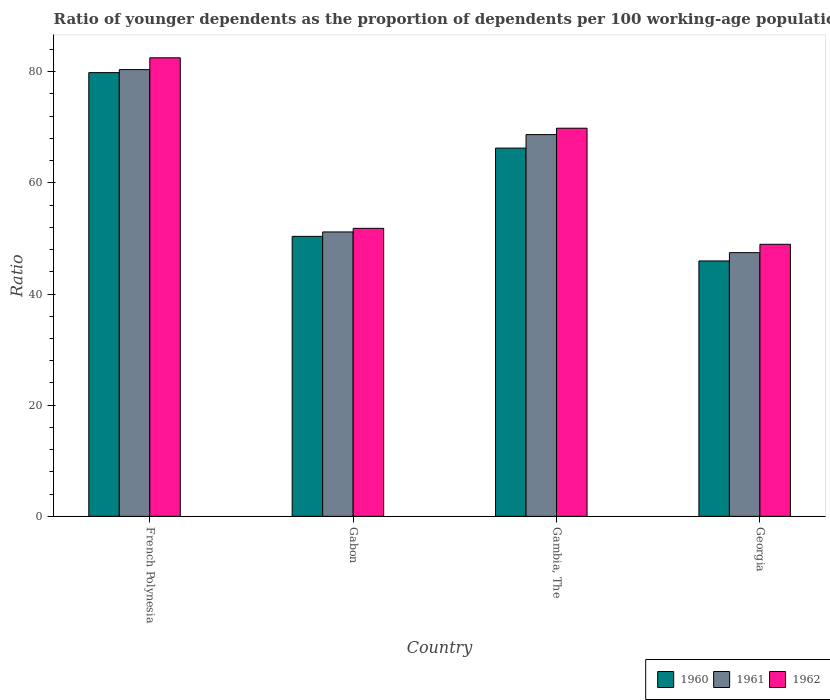Are the number of bars on each tick of the X-axis equal?
Give a very brief answer. Yes. How many bars are there on the 2nd tick from the left?
Provide a short and direct response. 3. What is the label of the 3rd group of bars from the left?
Your response must be concise. Gambia, The. In how many cases, is the number of bars for a given country not equal to the number of legend labels?
Provide a succinct answer. 0. What is the age dependency ratio(young) in 1961 in French Polynesia?
Your answer should be compact. 80.38. Across all countries, what is the maximum age dependency ratio(young) in 1960?
Provide a succinct answer. 79.84. Across all countries, what is the minimum age dependency ratio(young) in 1960?
Provide a succinct answer. 45.95. In which country was the age dependency ratio(young) in 1960 maximum?
Your response must be concise. French Polynesia. In which country was the age dependency ratio(young) in 1961 minimum?
Offer a terse response. Georgia. What is the total age dependency ratio(young) in 1961 in the graph?
Offer a terse response. 247.68. What is the difference between the age dependency ratio(young) in 1960 in Gambia, The and that in Georgia?
Ensure brevity in your answer.  20.31. What is the difference between the age dependency ratio(young) in 1961 in French Polynesia and the age dependency ratio(young) in 1962 in Gambia, The?
Ensure brevity in your answer.  10.54. What is the average age dependency ratio(young) in 1961 per country?
Keep it short and to the point. 61.92. What is the difference between the age dependency ratio(young) of/in 1960 and age dependency ratio(young) of/in 1962 in Georgia?
Provide a succinct answer. -3. What is the ratio of the age dependency ratio(young) in 1961 in French Polynesia to that in Gambia, The?
Your answer should be compact. 1.17. What is the difference between the highest and the second highest age dependency ratio(young) in 1962?
Your answer should be compact. 30.68. What is the difference between the highest and the lowest age dependency ratio(young) in 1960?
Make the answer very short. 33.89. Is the sum of the age dependency ratio(young) in 1960 in French Polynesia and Georgia greater than the maximum age dependency ratio(young) in 1962 across all countries?
Make the answer very short. Yes. What is the difference between two consecutive major ticks on the Y-axis?
Keep it short and to the point. 20. Does the graph contain any zero values?
Keep it short and to the point. No. Does the graph contain grids?
Offer a very short reply. No. How many legend labels are there?
Keep it short and to the point. 3. What is the title of the graph?
Your answer should be compact. Ratio of younger dependents as the proportion of dependents per 100 working-age population. What is the label or title of the X-axis?
Your response must be concise. Country. What is the label or title of the Y-axis?
Provide a short and direct response. Ratio. What is the Ratio in 1960 in French Polynesia?
Make the answer very short. 79.84. What is the Ratio of 1961 in French Polynesia?
Keep it short and to the point. 80.38. What is the Ratio of 1962 in French Polynesia?
Your response must be concise. 82.5. What is the Ratio of 1960 in Gabon?
Offer a terse response. 50.38. What is the Ratio in 1961 in Gabon?
Keep it short and to the point. 51.17. What is the Ratio of 1962 in Gabon?
Provide a succinct answer. 51.82. What is the Ratio in 1960 in Gambia, The?
Offer a terse response. 66.26. What is the Ratio in 1961 in Gambia, The?
Your answer should be compact. 68.69. What is the Ratio of 1962 in Gambia, The?
Your answer should be very brief. 69.84. What is the Ratio of 1960 in Georgia?
Provide a succinct answer. 45.95. What is the Ratio in 1961 in Georgia?
Keep it short and to the point. 47.45. What is the Ratio of 1962 in Georgia?
Keep it short and to the point. 48.95. Across all countries, what is the maximum Ratio of 1960?
Your answer should be compact. 79.84. Across all countries, what is the maximum Ratio in 1961?
Offer a terse response. 80.38. Across all countries, what is the maximum Ratio of 1962?
Offer a terse response. 82.5. Across all countries, what is the minimum Ratio in 1960?
Ensure brevity in your answer.  45.95. Across all countries, what is the minimum Ratio in 1961?
Keep it short and to the point. 47.45. Across all countries, what is the minimum Ratio in 1962?
Your answer should be compact. 48.95. What is the total Ratio of 1960 in the graph?
Your response must be concise. 242.42. What is the total Ratio of 1961 in the graph?
Provide a succinct answer. 247.68. What is the total Ratio of 1962 in the graph?
Ensure brevity in your answer.  253.11. What is the difference between the Ratio in 1960 in French Polynesia and that in Gabon?
Provide a short and direct response. 29.46. What is the difference between the Ratio of 1961 in French Polynesia and that in Gabon?
Offer a terse response. 29.21. What is the difference between the Ratio of 1962 in French Polynesia and that in Gabon?
Ensure brevity in your answer.  30.68. What is the difference between the Ratio of 1960 in French Polynesia and that in Gambia, The?
Your answer should be very brief. 13.58. What is the difference between the Ratio in 1961 in French Polynesia and that in Gambia, The?
Your answer should be compact. 11.69. What is the difference between the Ratio of 1962 in French Polynesia and that in Gambia, The?
Keep it short and to the point. 12.67. What is the difference between the Ratio of 1960 in French Polynesia and that in Georgia?
Give a very brief answer. 33.89. What is the difference between the Ratio of 1961 in French Polynesia and that in Georgia?
Offer a very short reply. 32.93. What is the difference between the Ratio in 1962 in French Polynesia and that in Georgia?
Your response must be concise. 33.56. What is the difference between the Ratio of 1960 in Gabon and that in Gambia, The?
Give a very brief answer. -15.88. What is the difference between the Ratio in 1961 in Gabon and that in Gambia, The?
Your answer should be very brief. -17.51. What is the difference between the Ratio of 1962 in Gabon and that in Gambia, The?
Your response must be concise. -18.02. What is the difference between the Ratio of 1960 in Gabon and that in Georgia?
Your answer should be very brief. 4.42. What is the difference between the Ratio of 1961 in Gabon and that in Georgia?
Your answer should be very brief. 3.73. What is the difference between the Ratio in 1962 in Gabon and that in Georgia?
Your response must be concise. 2.87. What is the difference between the Ratio in 1960 in Gambia, The and that in Georgia?
Make the answer very short. 20.31. What is the difference between the Ratio of 1961 in Gambia, The and that in Georgia?
Offer a terse response. 21.24. What is the difference between the Ratio in 1962 in Gambia, The and that in Georgia?
Provide a short and direct response. 20.89. What is the difference between the Ratio of 1960 in French Polynesia and the Ratio of 1961 in Gabon?
Provide a short and direct response. 28.67. What is the difference between the Ratio of 1960 in French Polynesia and the Ratio of 1962 in Gabon?
Ensure brevity in your answer.  28.02. What is the difference between the Ratio of 1961 in French Polynesia and the Ratio of 1962 in Gabon?
Your answer should be very brief. 28.56. What is the difference between the Ratio of 1960 in French Polynesia and the Ratio of 1961 in Gambia, The?
Your response must be concise. 11.15. What is the difference between the Ratio in 1960 in French Polynesia and the Ratio in 1962 in Gambia, The?
Provide a short and direct response. 10. What is the difference between the Ratio of 1961 in French Polynesia and the Ratio of 1962 in Gambia, The?
Provide a short and direct response. 10.54. What is the difference between the Ratio in 1960 in French Polynesia and the Ratio in 1961 in Georgia?
Provide a short and direct response. 32.39. What is the difference between the Ratio of 1960 in French Polynesia and the Ratio of 1962 in Georgia?
Your answer should be compact. 30.89. What is the difference between the Ratio of 1961 in French Polynesia and the Ratio of 1962 in Georgia?
Provide a short and direct response. 31.43. What is the difference between the Ratio in 1960 in Gabon and the Ratio in 1961 in Gambia, The?
Your answer should be compact. -18.31. What is the difference between the Ratio in 1960 in Gabon and the Ratio in 1962 in Gambia, The?
Give a very brief answer. -19.46. What is the difference between the Ratio of 1961 in Gabon and the Ratio of 1962 in Gambia, The?
Your answer should be compact. -18.66. What is the difference between the Ratio of 1960 in Gabon and the Ratio of 1961 in Georgia?
Your response must be concise. 2.93. What is the difference between the Ratio of 1960 in Gabon and the Ratio of 1962 in Georgia?
Give a very brief answer. 1.43. What is the difference between the Ratio in 1961 in Gabon and the Ratio in 1962 in Georgia?
Give a very brief answer. 2.22. What is the difference between the Ratio of 1960 in Gambia, The and the Ratio of 1961 in Georgia?
Ensure brevity in your answer.  18.81. What is the difference between the Ratio in 1960 in Gambia, The and the Ratio in 1962 in Georgia?
Make the answer very short. 17.31. What is the difference between the Ratio in 1961 in Gambia, The and the Ratio in 1962 in Georgia?
Provide a short and direct response. 19.74. What is the average Ratio in 1960 per country?
Give a very brief answer. 60.61. What is the average Ratio in 1961 per country?
Offer a very short reply. 61.92. What is the average Ratio in 1962 per country?
Give a very brief answer. 63.28. What is the difference between the Ratio of 1960 and Ratio of 1961 in French Polynesia?
Offer a very short reply. -0.54. What is the difference between the Ratio of 1960 and Ratio of 1962 in French Polynesia?
Make the answer very short. -2.67. What is the difference between the Ratio of 1961 and Ratio of 1962 in French Polynesia?
Provide a succinct answer. -2.13. What is the difference between the Ratio in 1960 and Ratio in 1961 in Gabon?
Provide a short and direct response. -0.8. What is the difference between the Ratio of 1960 and Ratio of 1962 in Gabon?
Give a very brief answer. -1.45. What is the difference between the Ratio of 1961 and Ratio of 1962 in Gabon?
Ensure brevity in your answer.  -0.65. What is the difference between the Ratio of 1960 and Ratio of 1961 in Gambia, The?
Give a very brief answer. -2.43. What is the difference between the Ratio in 1960 and Ratio in 1962 in Gambia, The?
Offer a terse response. -3.58. What is the difference between the Ratio of 1961 and Ratio of 1962 in Gambia, The?
Ensure brevity in your answer.  -1.15. What is the difference between the Ratio in 1960 and Ratio in 1961 in Georgia?
Provide a short and direct response. -1.49. What is the difference between the Ratio of 1960 and Ratio of 1962 in Georgia?
Offer a terse response. -3. What is the difference between the Ratio in 1961 and Ratio in 1962 in Georgia?
Provide a short and direct response. -1.5. What is the ratio of the Ratio of 1960 in French Polynesia to that in Gabon?
Make the answer very short. 1.58. What is the ratio of the Ratio in 1961 in French Polynesia to that in Gabon?
Give a very brief answer. 1.57. What is the ratio of the Ratio in 1962 in French Polynesia to that in Gabon?
Offer a very short reply. 1.59. What is the ratio of the Ratio of 1960 in French Polynesia to that in Gambia, The?
Provide a succinct answer. 1.21. What is the ratio of the Ratio in 1961 in French Polynesia to that in Gambia, The?
Offer a very short reply. 1.17. What is the ratio of the Ratio of 1962 in French Polynesia to that in Gambia, The?
Provide a short and direct response. 1.18. What is the ratio of the Ratio in 1960 in French Polynesia to that in Georgia?
Provide a succinct answer. 1.74. What is the ratio of the Ratio in 1961 in French Polynesia to that in Georgia?
Ensure brevity in your answer.  1.69. What is the ratio of the Ratio in 1962 in French Polynesia to that in Georgia?
Offer a terse response. 1.69. What is the ratio of the Ratio of 1960 in Gabon to that in Gambia, The?
Make the answer very short. 0.76. What is the ratio of the Ratio of 1961 in Gabon to that in Gambia, The?
Give a very brief answer. 0.74. What is the ratio of the Ratio in 1962 in Gabon to that in Gambia, The?
Your response must be concise. 0.74. What is the ratio of the Ratio of 1960 in Gabon to that in Georgia?
Offer a terse response. 1.1. What is the ratio of the Ratio in 1961 in Gabon to that in Georgia?
Provide a short and direct response. 1.08. What is the ratio of the Ratio in 1962 in Gabon to that in Georgia?
Your response must be concise. 1.06. What is the ratio of the Ratio of 1960 in Gambia, The to that in Georgia?
Offer a very short reply. 1.44. What is the ratio of the Ratio of 1961 in Gambia, The to that in Georgia?
Keep it short and to the point. 1.45. What is the ratio of the Ratio of 1962 in Gambia, The to that in Georgia?
Your answer should be very brief. 1.43. What is the difference between the highest and the second highest Ratio of 1960?
Your answer should be very brief. 13.58. What is the difference between the highest and the second highest Ratio of 1961?
Offer a terse response. 11.69. What is the difference between the highest and the second highest Ratio in 1962?
Your answer should be compact. 12.67. What is the difference between the highest and the lowest Ratio in 1960?
Keep it short and to the point. 33.89. What is the difference between the highest and the lowest Ratio in 1961?
Give a very brief answer. 32.93. What is the difference between the highest and the lowest Ratio in 1962?
Make the answer very short. 33.56. 